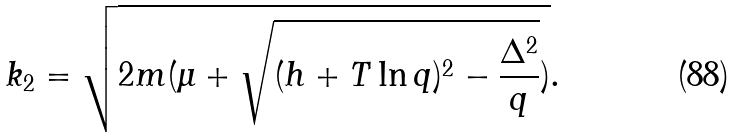Convert formula to latex. <formula><loc_0><loc_0><loc_500><loc_500>k _ { 2 } = \sqrt { 2 m ( \mu + \sqrt { ( h + T \ln q ) ^ { 2 } - \frac { \Delta ^ { 2 } } { q } } ) } .</formula> 